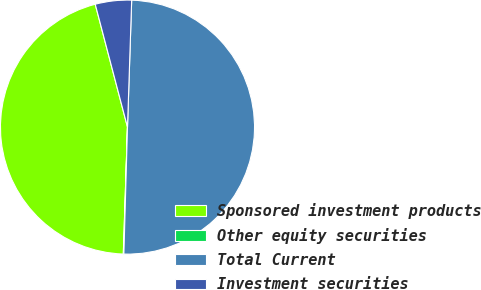Convert chart. <chart><loc_0><loc_0><loc_500><loc_500><pie_chart><fcel>Sponsored investment products<fcel>Other equity securities<fcel>Total Current<fcel>Investment securities<nl><fcel>45.39%<fcel>0.07%<fcel>49.93%<fcel>4.61%<nl></chart> 